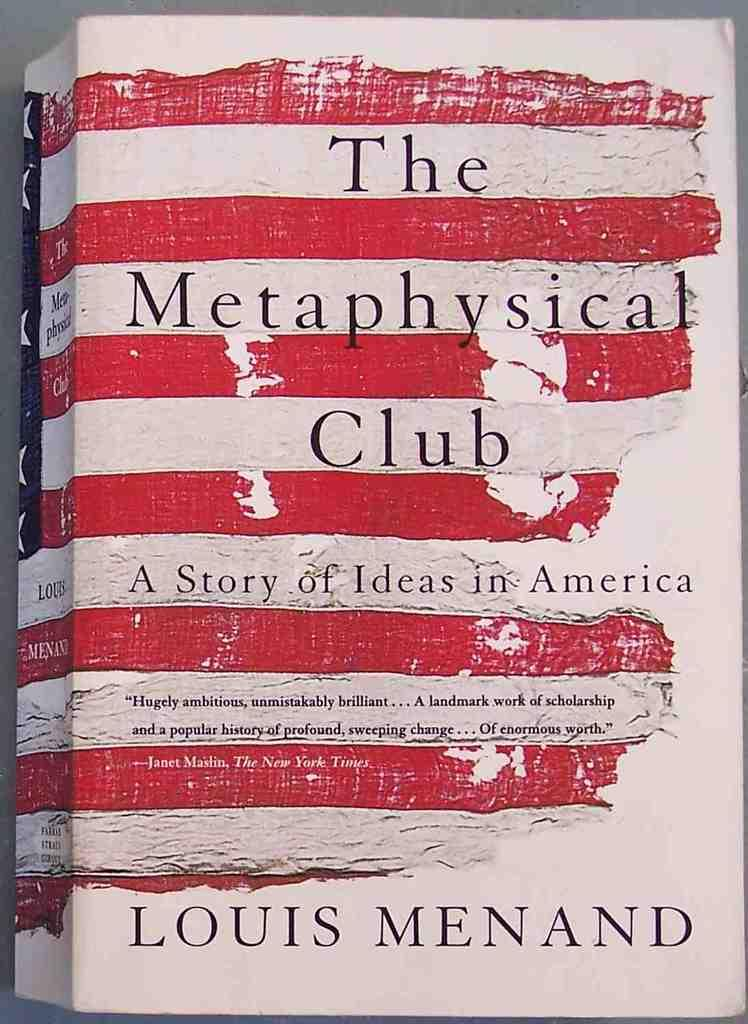<image>
Summarize the visual content of the image. A book called the metaphysical club by louis menand 